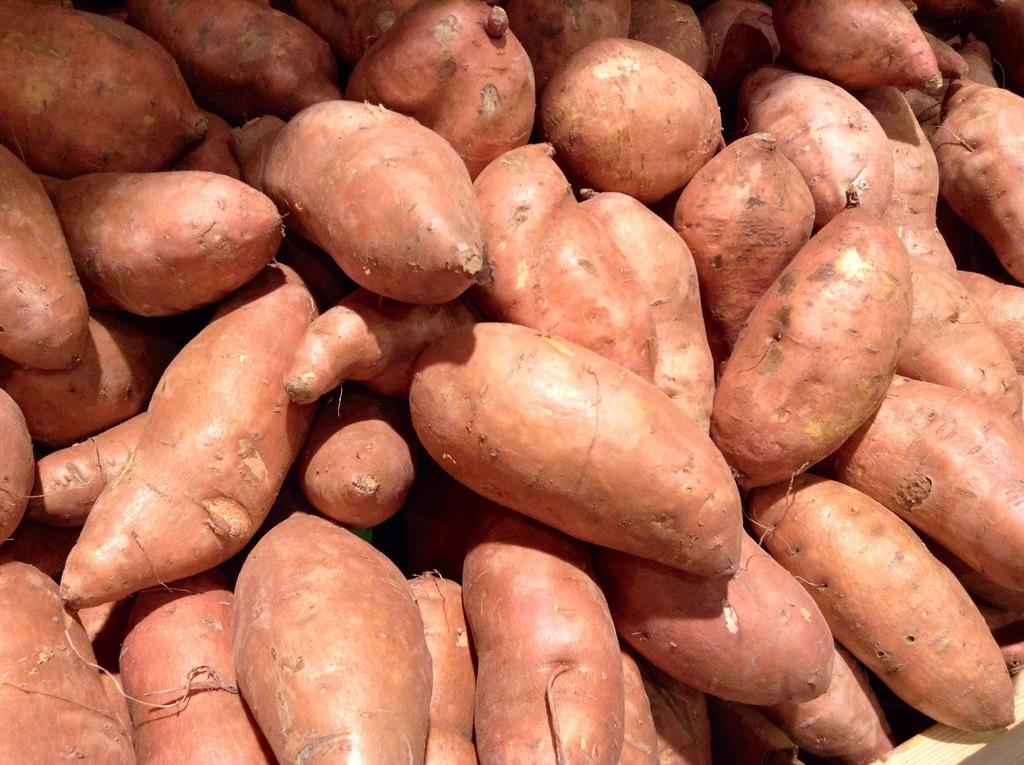What type of food is present in the image? The image contains sweet potatoes. Are there any other types of food visible in the image? The provided facts only mention sweet potatoes, so we cannot definitively say if there are other types of food present. What type of chair is depicted in the image? There is no chair present in the image; it only contains sweet potatoes. What type of authority is shown in the image? There is no authority figure present in the image; it only contains sweet potatoes. 